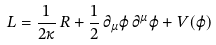Convert formula to latex. <formula><loc_0><loc_0><loc_500><loc_500>L = \frac { 1 } { 2 \kappa } \, R + \frac { 1 } { 2 } \, \partial _ { \mu } \varphi \, \partial ^ { \mu } \varphi + V ( \varphi )</formula> 